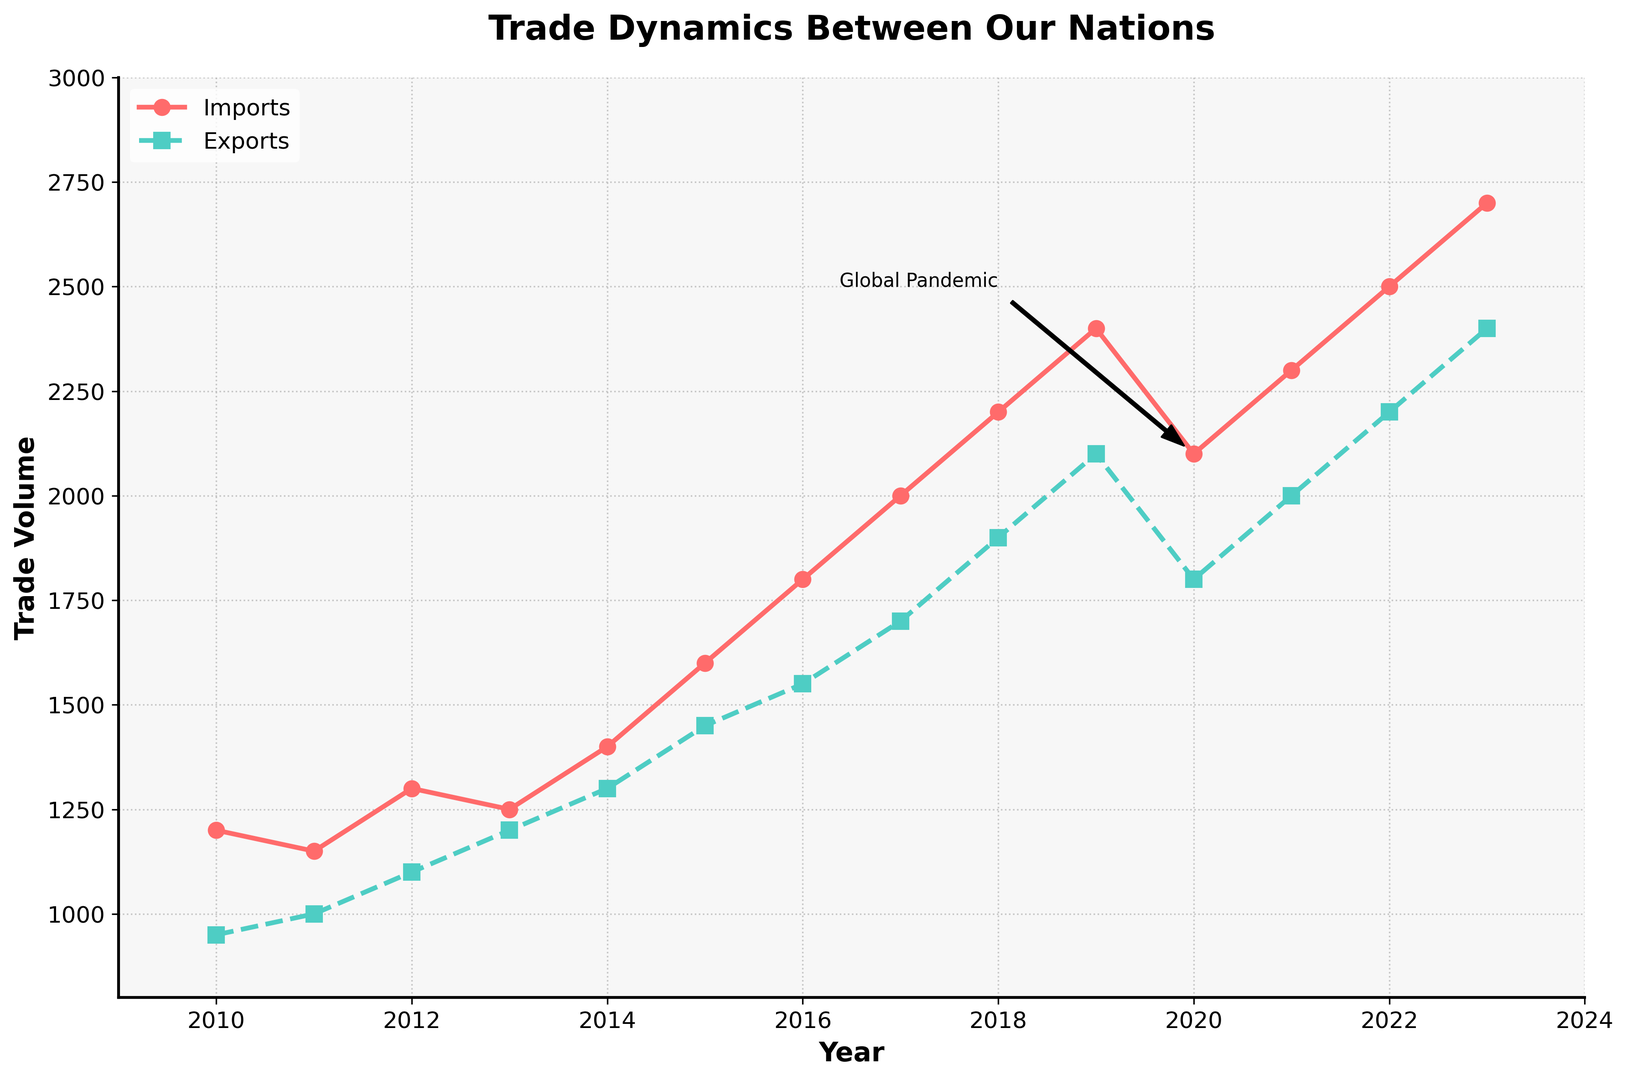What year did imports surpass 2000 units? The import line crossed 2000 units in 2017. By closely examining the figure, you can observe that the imports line first breaks above the 2000 units mark in the year 2017.
Answer: 2017 Was the trade volume for exports consistently increasing from 2010 to 2023? Starting from 2010, exports show a general upward trend with yearly increases. Two exceptions are observed: in 2020, exports decreased relative to 2019, but after that, the upward trend resumed without further interruptions until 2023.
Answer: No What was the difference in trade volume between imports and exports in 2015? In 2015, imports were 1600 and exports were 1450. The difference can be calculated as 1600 - 1450 = 150.
Answer: 150 During which period was the growth in imports the steepest? By examining the steepness of the imports line on the chart, the period from 2015 to 2018 shows the most pronounced growth. In this period, imports rose substantially from 1600 to 2200 units, an increase of 600 units.
Answer: 2015-2018 Which year marked a decline in both imports and exports relative to the previous year? Both imports and exports saw declines in the year 2020 as compared to 2019. The plotted lines for both imports and exports dip noticeably between these two years, likely due to the impact highlighted by the annotation 'Global Pandemic.'
Answer: 2020 How do imports in 2023 compare with imports in 2010? By consulting the start and end points of the imports line on the plot, it's evident that imports grew from 1200 units in 2010 to 2700 units in 2023. Comparatively, imports in 2023 are 1500 units higher than in 2010.
Answer: 1500 units higher From 2011 to 2014, how much did exports increase? Exports in 2011 were 1000 units, and by 2014, they rose to 1300 units. The increase can be calculated as 1300 - 1000 = 300 units over this period.
Answer: 300 units Is there a year where exports and imports have the same value? According to the figure, at no point do the import and export lines intersect, indicating that there is no year where the values of exports and imports are the same.
Answer: No What was the average trade volume of imports from 2020 to 2023? The values of imports for the years 2020, 2021, 2022, and 2023 are 2100, 2300, 2500, and 2700 respectively. The average can be calculated by summing these values and dividing by 4: (2100+2300+2500+2700) / 4 = 2400.
Answer: 2400 Between 2013 and 2016, did imports or exports grow more? From 2013 to 2016, imports grew from 1250 to 1800 units, which is an increase of 550 units. Exports grew from 1200 to 1550 units during the same period, a 350 unit increase. Hence, imports experienced a greater growth.
Answer: Imports Which year's trade volumes were spotlighted by the annotation 'Global Pandemic'? The annotation pointing to 'Global Pandemic' is connected to the year 2020, emphasizing the notable economic impact during that time.
Answer: 2020 